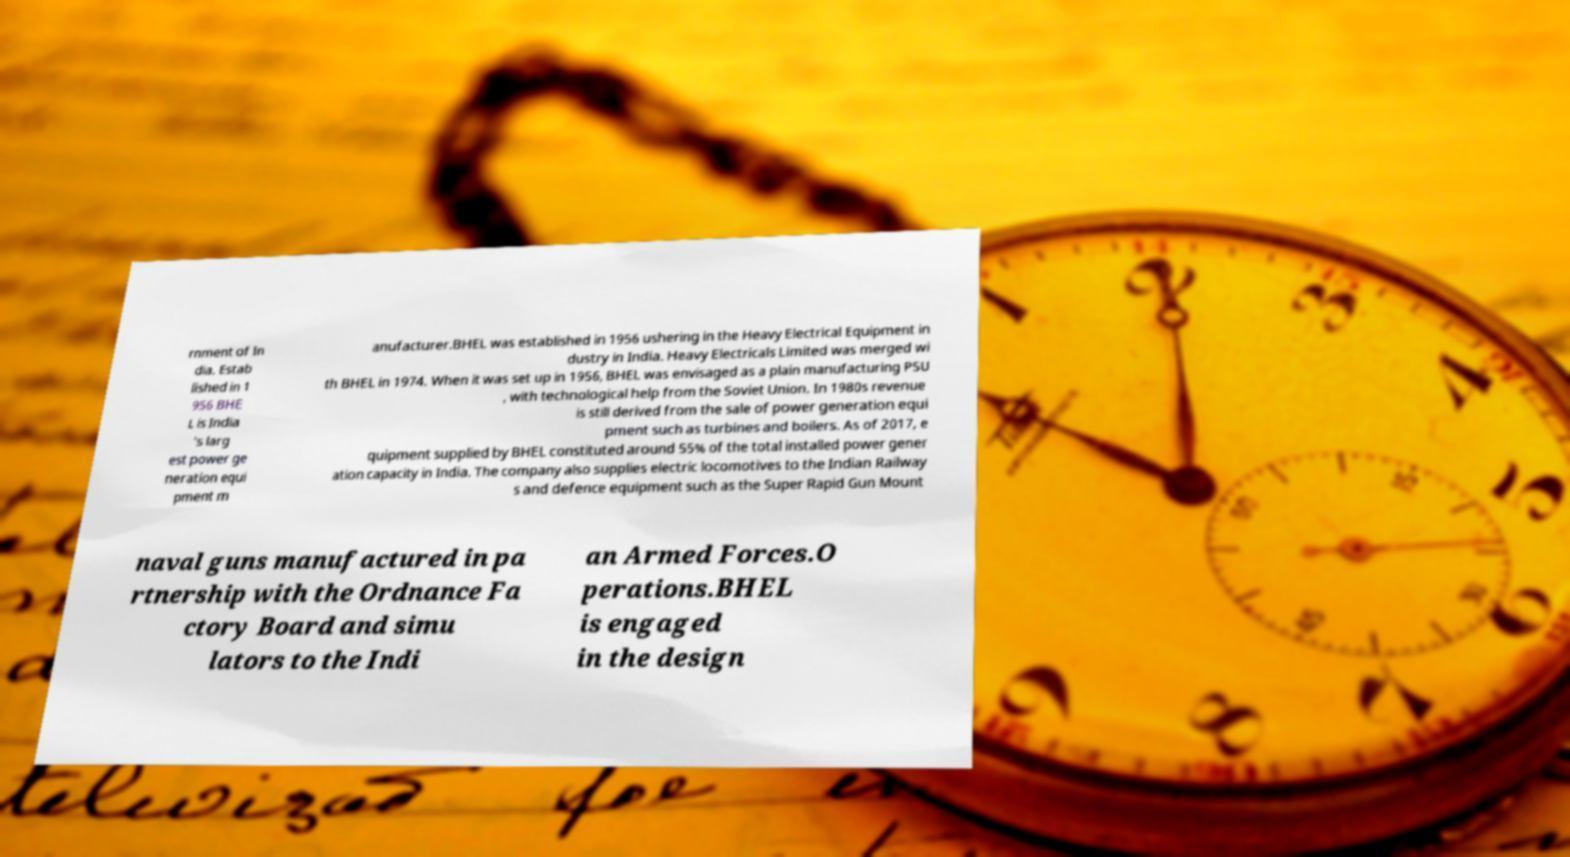Could you assist in decoding the text presented in this image and type it out clearly? rnment of In dia. Estab lished in 1 956 BHE L is India 's larg est power ge neration equi pment m anufacturer.BHEL was established in 1956 ushering in the Heavy Electrical Equipment in dustry in India. Heavy Electricals Limited was merged wi th BHEL in 1974. When it was set up in 1956, BHEL was envisaged as a plain manufacturing PSU , with technological help from the Soviet Union. In 1980s revenue is still derived from the sale of power generation equi pment such as turbines and boilers. As of 2017, e quipment supplied by BHEL constituted around 55% of the total installed power gener ation capacity in India. The company also supplies electric locomotives to the Indian Railway s and defence equipment such as the Super Rapid Gun Mount naval guns manufactured in pa rtnership with the Ordnance Fa ctory Board and simu lators to the Indi an Armed Forces.O perations.BHEL is engaged in the design 